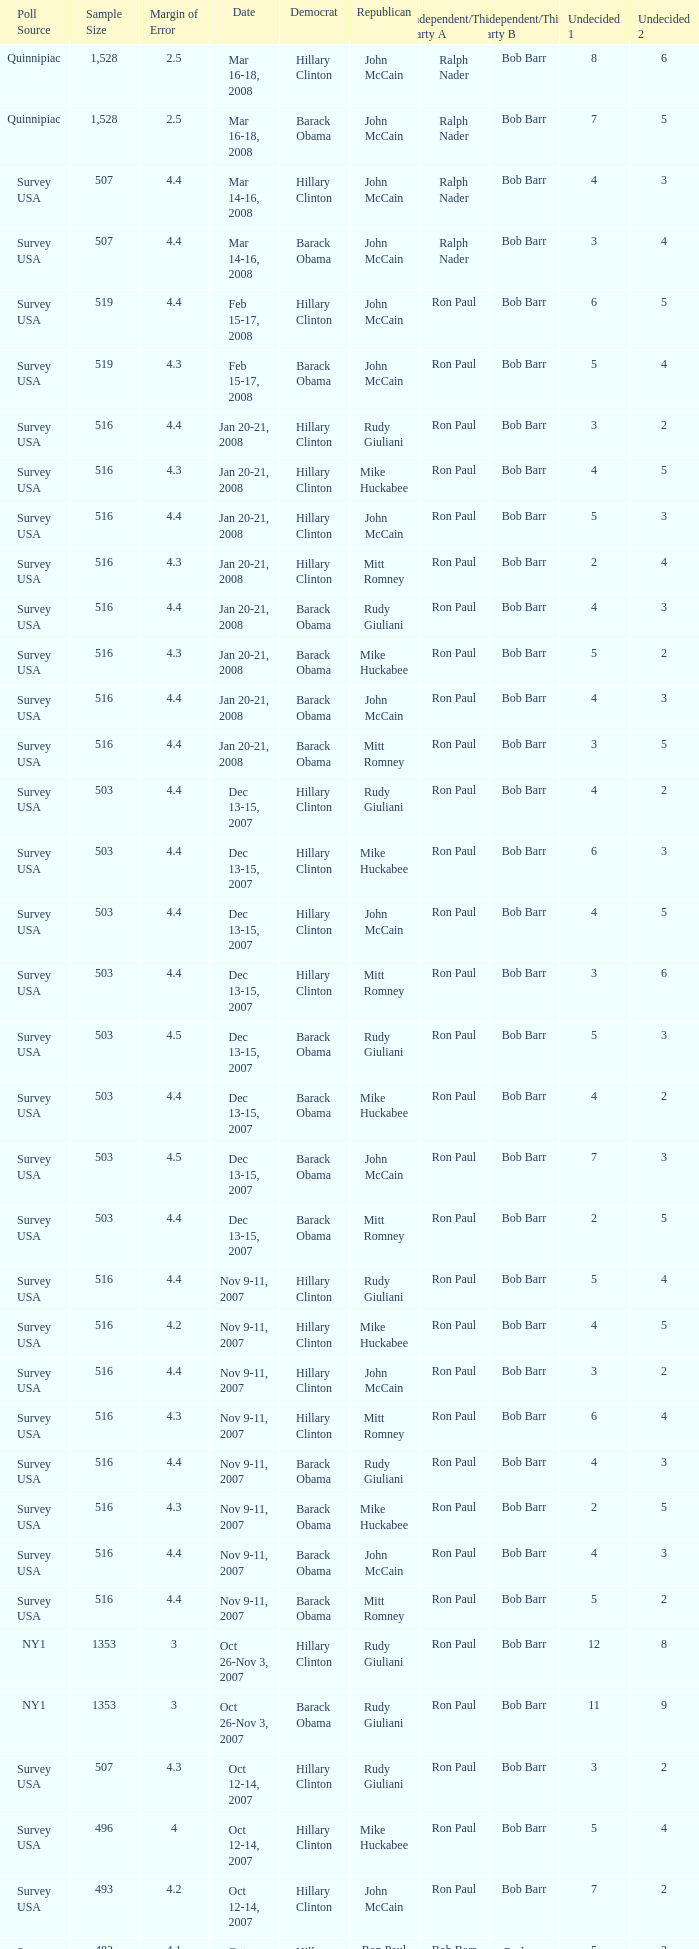What was the date of the poll with a sample size of 496 where Republican Mike Huckabee was chosen? Oct 12-14, 2007. 